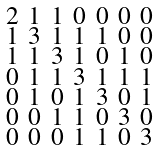Convert formula to latex. <formula><loc_0><loc_0><loc_500><loc_500>\begin{smallmatrix} 2 & 1 & 1 & 0 & 0 & 0 & 0 \\ 1 & 3 & 1 & 1 & 1 & 0 & 0 \\ 1 & 1 & 3 & 1 & 0 & 1 & 0 \\ 0 & 1 & 1 & 3 & 1 & 1 & 1 \\ 0 & 1 & 0 & 1 & 3 & 0 & 1 \\ 0 & 0 & 1 & 1 & 0 & 3 & 0 \\ 0 & 0 & 0 & 1 & 1 & 0 & 3 \end{smallmatrix}</formula> 